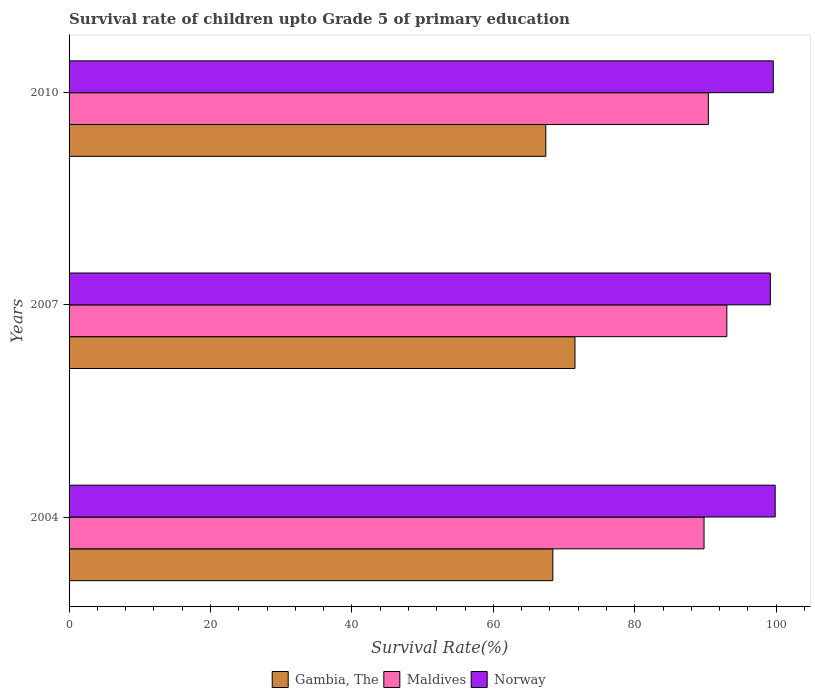How many different coloured bars are there?
Offer a terse response. 3. How many bars are there on the 3rd tick from the top?
Offer a very short reply. 3. How many bars are there on the 2nd tick from the bottom?
Your response must be concise. 3. In how many cases, is the number of bars for a given year not equal to the number of legend labels?
Ensure brevity in your answer.  0. What is the survival rate of children in Maldives in 2004?
Your response must be concise. 89.79. Across all years, what is the maximum survival rate of children in Maldives?
Give a very brief answer. 93.01. Across all years, what is the minimum survival rate of children in Maldives?
Give a very brief answer. 89.79. In which year was the survival rate of children in Gambia, The maximum?
Your answer should be very brief. 2007. In which year was the survival rate of children in Maldives minimum?
Your answer should be very brief. 2004. What is the total survival rate of children in Gambia, The in the graph?
Your answer should be compact. 207.37. What is the difference between the survival rate of children in Gambia, The in 2004 and that in 2007?
Your answer should be very brief. -3.13. What is the difference between the survival rate of children in Maldives in 2004 and the survival rate of children in Gambia, The in 2010?
Offer a very short reply. 22.38. What is the average survival rate of children in Norway per year?
Provide a short and direct response. 99.54. In the year 2010, what is the difference between the survival rate of children in Norway and survival rate of children in Gambia, The?
Keep it short and to the point. 32.17. In how many years, is the survival rate of children in Norway greater than 48 %?
Give a very brief answer. 3. What is the ratio of the survival rate of children in Maldives in 2004 to that in 2007?
Offer a terse response. 0.97. Is the survival rate of children in Norway in 2004 less than that in 2007?
Your answer should be very brief. No. What is the difference between the highest and the second highest survival rate of children in Gambia, The?
Your answer should be very brief. 3.13. What is the difference between the highest and the lowest survival rate of children in Gambia, The?
Provide a succinct answer. 4.12. What does the 3rd bar from the top in 2010 represents?
Make the answer very short. Gambia, The. What does the 3rd bar from the bottom in 2004 represents?
Your answer should be very brief. Norway. How many bars are there?
Keep it short and to the point. 9. Are all the bars in the graph horizontal?
Your response must be concise. Yes. What is the difference between two consecutive major ticks on the X-axis?
Offer a very short reply. 20. Does the graph contain any zero values?
Provide a short and direct response. No. Does the graph contain grids?
Ensure brevity in your answer.  No. How are the legend labels stacked?
Offer a very short reply. Horizontal. What is the title of the graph?
Offer a very short reply. Survival rate of children upto Grade 5 of primary education. What is the label or title of the X-axis?
Your answer should be very brief. Survival Rate(%). What is the label or title of the Y-axis?
Give a very brief answer. Years. What is the Survival Rate(%) of Gambia, The in 2004?
Give a very brief answer. 68.41. What is the Survival Rate(%) of Maldives in 2004?
Your response must be concise. 89.79. What is the Survival Rate(%) in Norway in 2004?
Keep it short and to the point. 99.85. What is the Survival Rate(%) of Gambia, The in 2007?
Offer a terse response. 71.54. What is the Survival Rate(%) in Maldives in 2007?
Provide a short and direct response. 93.01. What is the Survival Rate(%) in Norway in 2007?
Give a very brief answer. 99.17. What is the Survival Rate(%) in Gambia, The in 2010?
Your answer should be very brief. 67.41. What is the Survival Rate(%) of Maldives in 2010?
Ensure brevity in your answer.  90.4. What is the Survival Rate(%) in Norway in 2010?
Provide a short and direct response. 99.58. Across all years, what is the maximum Survival Rate(%) of Gambia, The?
Ensure brevity in your answer.  71.54. Across all years, what is the maximum Survival Rate(%) in Maldives?
Provide a succinct answer. 93.01. Across all years, what is the maximum Survival Rate(%) in Norway?
Ensure brevity in your answer.  99.85. Across all years, what is the minimum Survival Rate(%) of Gambia, The?
Keep it short and to the point. 67.41. Across all years, what is the minimum Survival Rate(%) in Maldives?
Provide a short and direct response. 89.79. Across all years, what is the minimum Survival Rate(%) in Norway?
Your response must be concise. 99.17. What is the total Survival Rate(%) of Gambia, The in the graph?
Make the answer very short. 207.37. What is the total Survival Rate(%) of Maldives in the graph?
Make the answer very short. 273.21. What is the total Survival Rate(%) in Norway in the graph?
Ensure brevity in your answer.  298.61. What is the difference between the Survival Rate(%) in Gambia, The in 2004 and that in 2007?
Ensure brevity in your answer.  -3.13. What is the difference between the Survival Rate(%) in Maldives in 2004 and that in 2007?
Your answer should be compact. -3.22. What is the difference between the Survival Rate(%) of Norway in 2004 and that in 2007?
Provide a succinct answer. 0.68. What is the difference between the Survival Rate(%) of Gambia, The in 2004 and that in 2010?
Offer a very short reply. 1. What is the difference between the Survival Rate(%) of Maldives in 2004 and that in 2010?
Provide a short and direct response. -0.61. What is the difference between the Survival Rate(%) in Norway in 2004 and that in 2010?
Make the answer very short. 0.27. What is the difference between the Survival Rate(%) of Gambia, The in 2007 and that in 2010?
Provide a succinct answer. 4.12. What is the difference between the Survival Rate(%) of Maldives in 2007 and that in 2010?
Give a very brief answer. 2.61. What is the difference between the Survival Rate(%) in Norway in 2007 and that in 2010?
Your answer should be compact. -0.41. What is the difference between the Survival Rate(%) in Gambia, The in 2004 and the Survival Rate(%) in Maldives in 2007?
Your answer should be compact. -24.6. What is the difference between the Survival Rate(%) of Gambia, The in 2004 and the Survival Rate(%) of Norway in 2007?
Offer a terse response. -30.76. What is the difference between the Survival Rate(%) in Maldives in 2004 and the Survival Rate(%) in Norway in 2007?
Provide a short and direct response. -9.38. What is the difference between the Survival Rate(%) of Gambia, The in 2004 and the Survival Rate(%) of Maldives in 2010?
Give a very brief answer. -21.99. What is the difference between the Survival Rate(%) of Gambia, The in 2004 and the Survival Rate(%) of Norway in 2010?
Keep it short and to the point. -31.17. What is the difference between the Survival Rate(%) of Maldives in 2004 and the Survival Rate(%) of Norway in 2010?
Offer a terse response. -9.79. What is the difference between the Survival Rate(%) in Gambia, The in 2007 and the Survival Rate(%) in Maldives in 2010?
Provide a short and direct response. -18.86. What is the difference between the Survival Rate(%) of Gambia, The in 2007 and the Survival Rate(%) of Norway in 2010?
Offer a very short reply. -28.04. What is the difference between the Survival Rate(%) in Maldives in 2007 and the Survival Rate(%) in Norway in 2010?
Provide a succinct answer. -6.57. What is the average Survival Rate(%) of Gambia, The per year?
Keep it short and to the point. 69.12. What is the average Survival Rate(%) of Maldives per year?
Your answer should be compact. 91.07. What is the average Survival Rate(%) in Norway per year?
Your answer should be very brief. 99.54. In the year 2004, what is the difference between the Survival Rate(%) in Gambia, The and Survival Rate(%) in Maldives?
Provide a succinct answer. -21.38. In the year 2004, what is the difference between the Survival Rate(%) of Gambia, The and Survival Rate(%) of Norway?
Your answer should be compact. -31.44. In the year 2004, what is the difference between the Survival Rate(%) of Maldives and Survival Rate(%) of Norway?
Provide a short and direct response. -10.06. In the year 2007, what is the difference between the Survival Rate(%) in Gambia, The and Survival Rate(%) in Maldives?
Your answer should be compact. -21.47. In the year 2007, what is the difference between the Survival Rate(%) of Gambia, The and Survival Rate(%) of Norway?
Your answer should be compact. -27.63. In the year 2007, what is the difference between the Survival Rate(%) in Maldives and Survival Rate(%) in Norway?
Provide a short and direct response. -6.16. In the year 2010, what is the difference between the Survival Rate(%) in Gambia, The and Survival Rate(%) in Maldives?
Ensure brevity in your answer.  -22.99. In the year 2010, what is the difference between the Survival Rate(%) of Gambia, The and Survival Rate(%) of Norway?
Give a very brief answer. -32.17. In the year 2010, what is the difference between the Survival Rate(%) in Maldives and Survival Rate(%) in Norway?
Ensure brevity in your answer.  -9.18. What is the ratio of the Survival Rate(%) in Gambia, The in 2004 to that in 2007?
Your answer should be very brief. 0.96. What is the ratio of the Survival Rate(%) in Maldives in 2004 to that in 2007?
Ensure brevity in your answer.  0.97. What is the ratio of the Survival Rate(%) of Norway in 2004 to that in 2007?
Give a very brief answer. 1.01. What is the ratio of the Survival Rate(%) in Gambia, The in 2004 to that in 2010?
Provide a short and direct response. 1.01. What is the ratio of the Survival Rate(%) of Gambia, The in 2007 to that in 2010?
Your response must be concise. 1.06. What is the ratio of the Survival Rate(%) of Maldives in 2007 to that in 2010?
Provide a succinct answer. 1.03. What is the difference between the highest and the second highest Survival Rate(%) of Gambia, The?
Your answer should be compact. 3.13. What is the difference between the highest and the second highest Survival Rate(%) of Maldives?
Your response must be concise. 2.61. What is the difference between the highest and the second highest Survival Rate(%) in Norway?
Keep it short and to the point. 0.27. What is the difference between the highest and the lowest Survival Rate(%) in Gambia, The?
Your answer should be compact. 4.12. What is the difference between the highest and the lowest Survival Rate(%) of Maldives?
Keep it short and to the point. 3.22. What is the difference between the highest and the lowest Survival Rate(%) in Norway?
Ensure brevity in your answer.  0.68. 